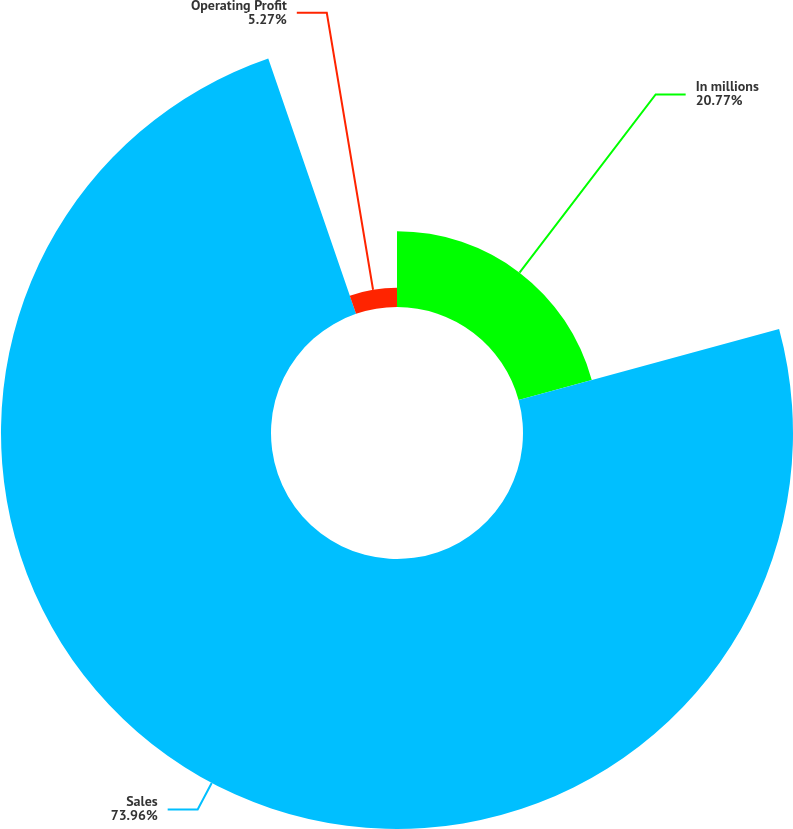Convert chart to OTSL. <chart><loc_0><loc_0><loc_500><loc_500><pie_chart><fcel>In millions<fcel>Sales<fcel>Operating Profit<nl><fcel>20.77%<fcel>73.96%<fcel>5.27%<nl></chart> 